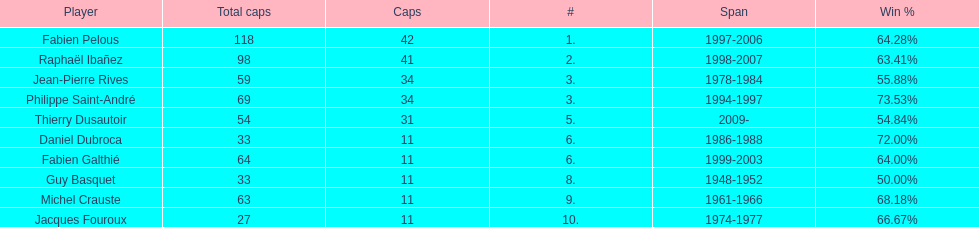How many caps did guy basquet accrue during his career? 33. 